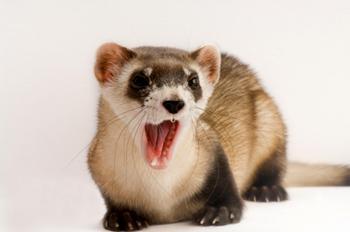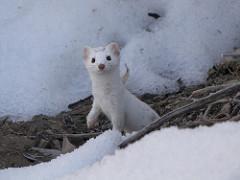The first image is the image on the left, the second image is the image on the right. Examine the images to the left and right. Is the description "at least one ferret is standing on the dirt with tufts of grass around it in the image pair" accurate? Answer yes or no. No. The first image is the image on the left, the second image is the image on the right. For the images shown, is this caption "There are two weasels that have black and white coloring." true? Answer yes or no. No. 